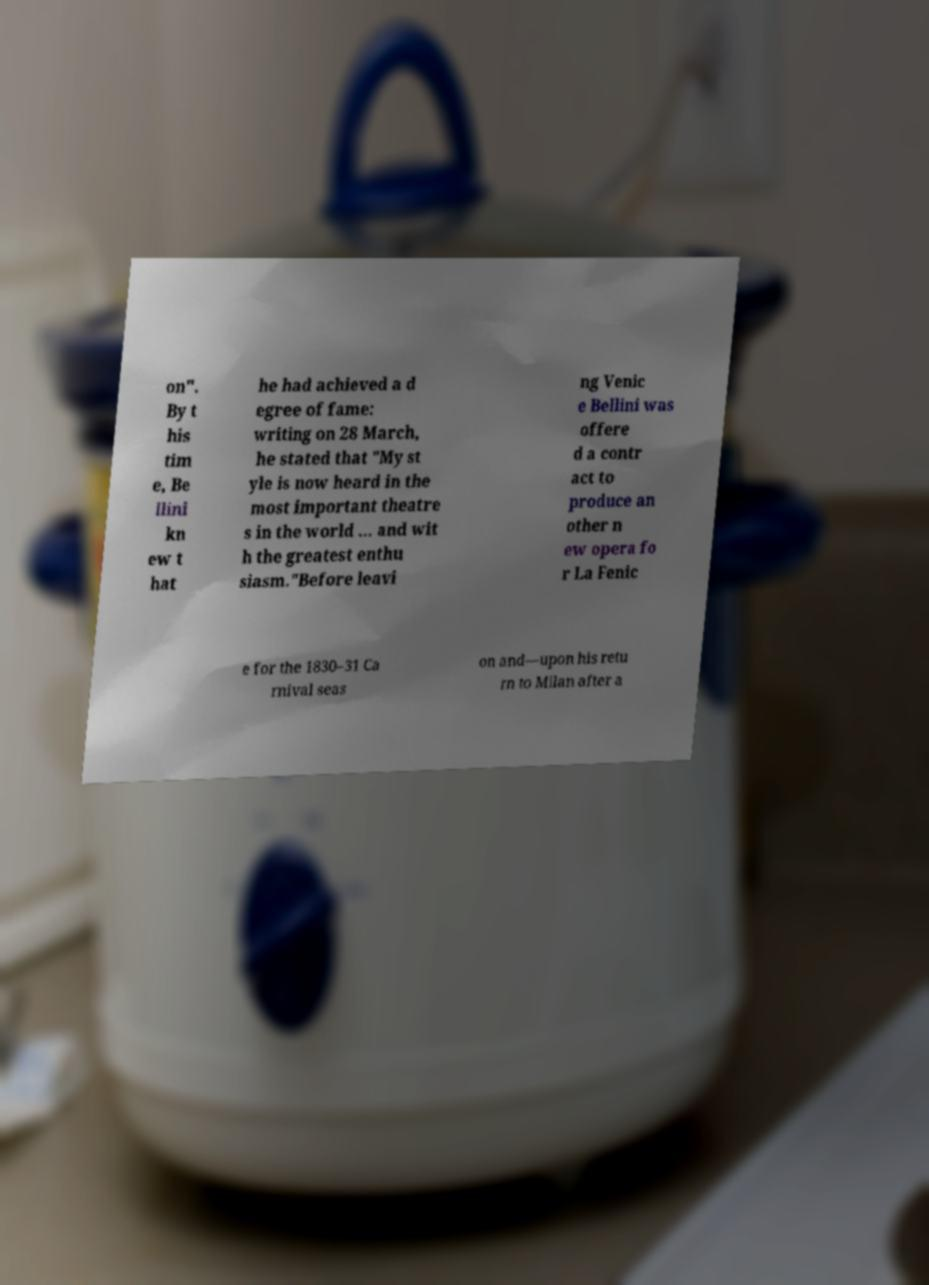Can you read and provide the text displayed in the image?This photo seems to have some interesting text. Can you extract and type it out for me? on". By t his tim e, Be llini kn ew t hat he had achieved a d egree of fame: writing on 28 March, he stated that "My st yle is now heard in the most important theatre s in the world ... and wit h the greatest enthu siasm."Before leavi ng Venic e Bellini was offere d a contr act to produce an other n ew opera fo r La Fenic e for the 1830–31 Ca rnival seas on and—upon his retu rn to Milan after a 